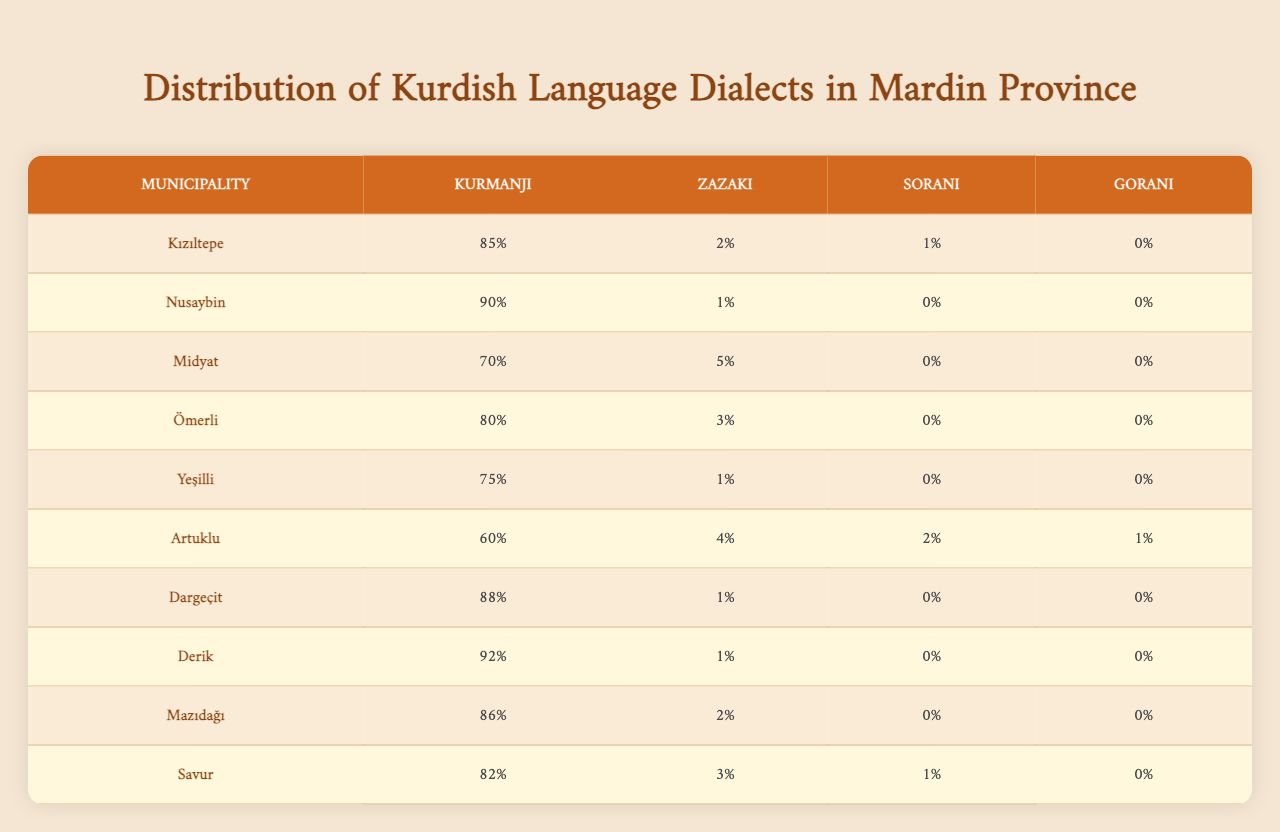What is the percentage of Kurmanji speakers in Kızıltepe? The table indicates that 85% of the population in Kızıltepe speaks Kurmanji.
Answer: 85% Which municipality has the highest percentage of Zazaki speakers? The highest percentage of Zazaki speakers is found in Artuklu, where 4% of the population speaks this dialect.
Answer: Artuklu What is the total percentage of Sorani speakers across all municipalities? By summing the Sorani percentages from all municipalities, we find 1% in Artuklu and 0% elsewhere, resulting in a total of 1%.
Answer: 1% Is anyone in Nusaybin speaking Sorani? The table shows that the percentage of Sorani speakers in Nusaybin is 0%, meaning no one speaks this dialect here.
Answer: No Which municipality has the lowest percentage of Kurmanji speakers? The municipality with the lowest percentage of Kurmanji speakers is Artuklu with 60%.
Answer: Artuklu What is the average percentage of Gorani speakers across all municipalities? The only municipality where Gorani is spoken is Artuklu, with 1%, so the average is also 1% (1/10).
Answer: 0.1% How does the percentage of Zazaki speakers in Ömerli compare to that in Savur? In Ömerli, there is a 3% Zazaki-speaking population, while Savur has 3%. Therefore, they are equal.
Answer: They are equal Which dialect is most commonly spoken in Derik? The table indicates that Kurmanji is the most commonly spoken dialect in Derik, with 92%.
Answer: Kurmanji What is the difference in Kurmanji speakers between Kızıltepe and Midyat? Kızıltepe has 85% Kurmanji speakers, while Midyat has 70%. The difference is 85% - 70% = 15%.
Answer: 15% Which municipality shows the least diversity in dialects, speaking primarily Kurmanji? Derik shows the least diversity with 92% Kurmanji, and no significant percentages in other dialects.
Answer: Derik 